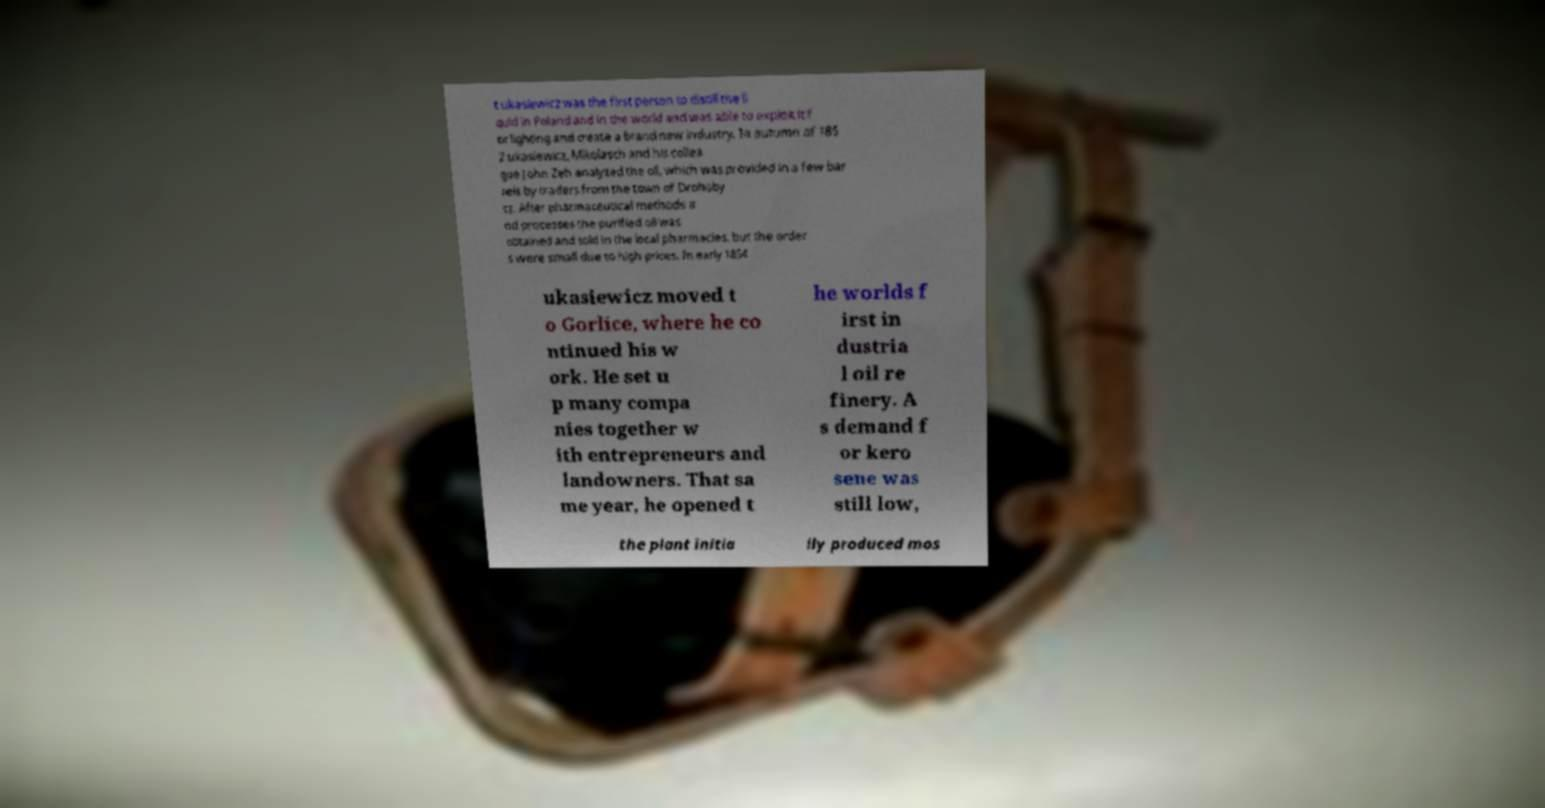Could you assist in decoding the text presented in this image and type it out clearly? t ukasiewicz was the first person to distill the li quid in Poland and in the world and was able to exploit it f or lighting and create a brand new industry. In autumn of 185 2 ukasiewicz, Mikolasch and his collea gue John Zeh analyzed the oil, which was provided in a few bar rels by traders from the town of Drohoby cz. After pharmaceutical methods a nd processes the purified oil was obtained and sold in the local pharmacies, but the order s were small due to high prices. In early 1854 ukasiewicz moved t o Gorlice, where he co ntinued his w ork. He set u p many compa nies together w ith entrepreneurs and landowners. That sa me year, he opened t he worlds f irst in dustria l oil re finery. A s demand f or kero sene was still low, the plant initia lly produced mos 